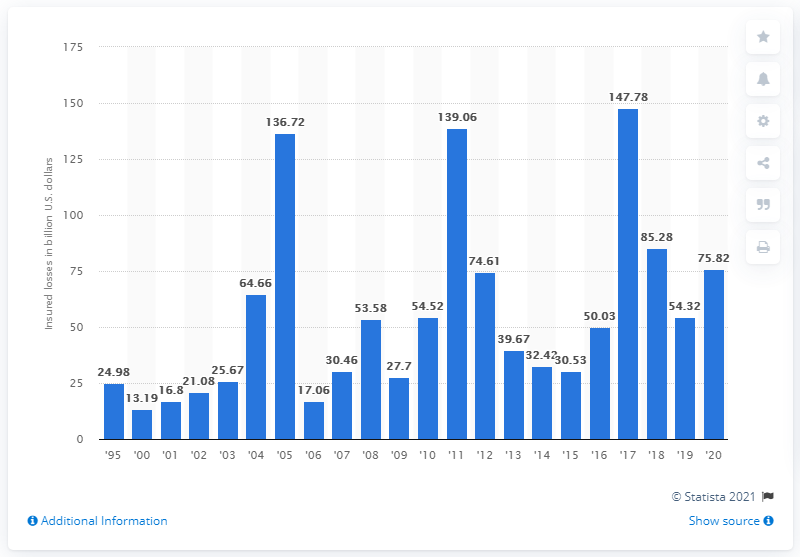Point out several critical features in this image. According to the data, the worldwide insured losses resulting from natural disasters in 2020 amounted to approximately 75.82 dollars. 